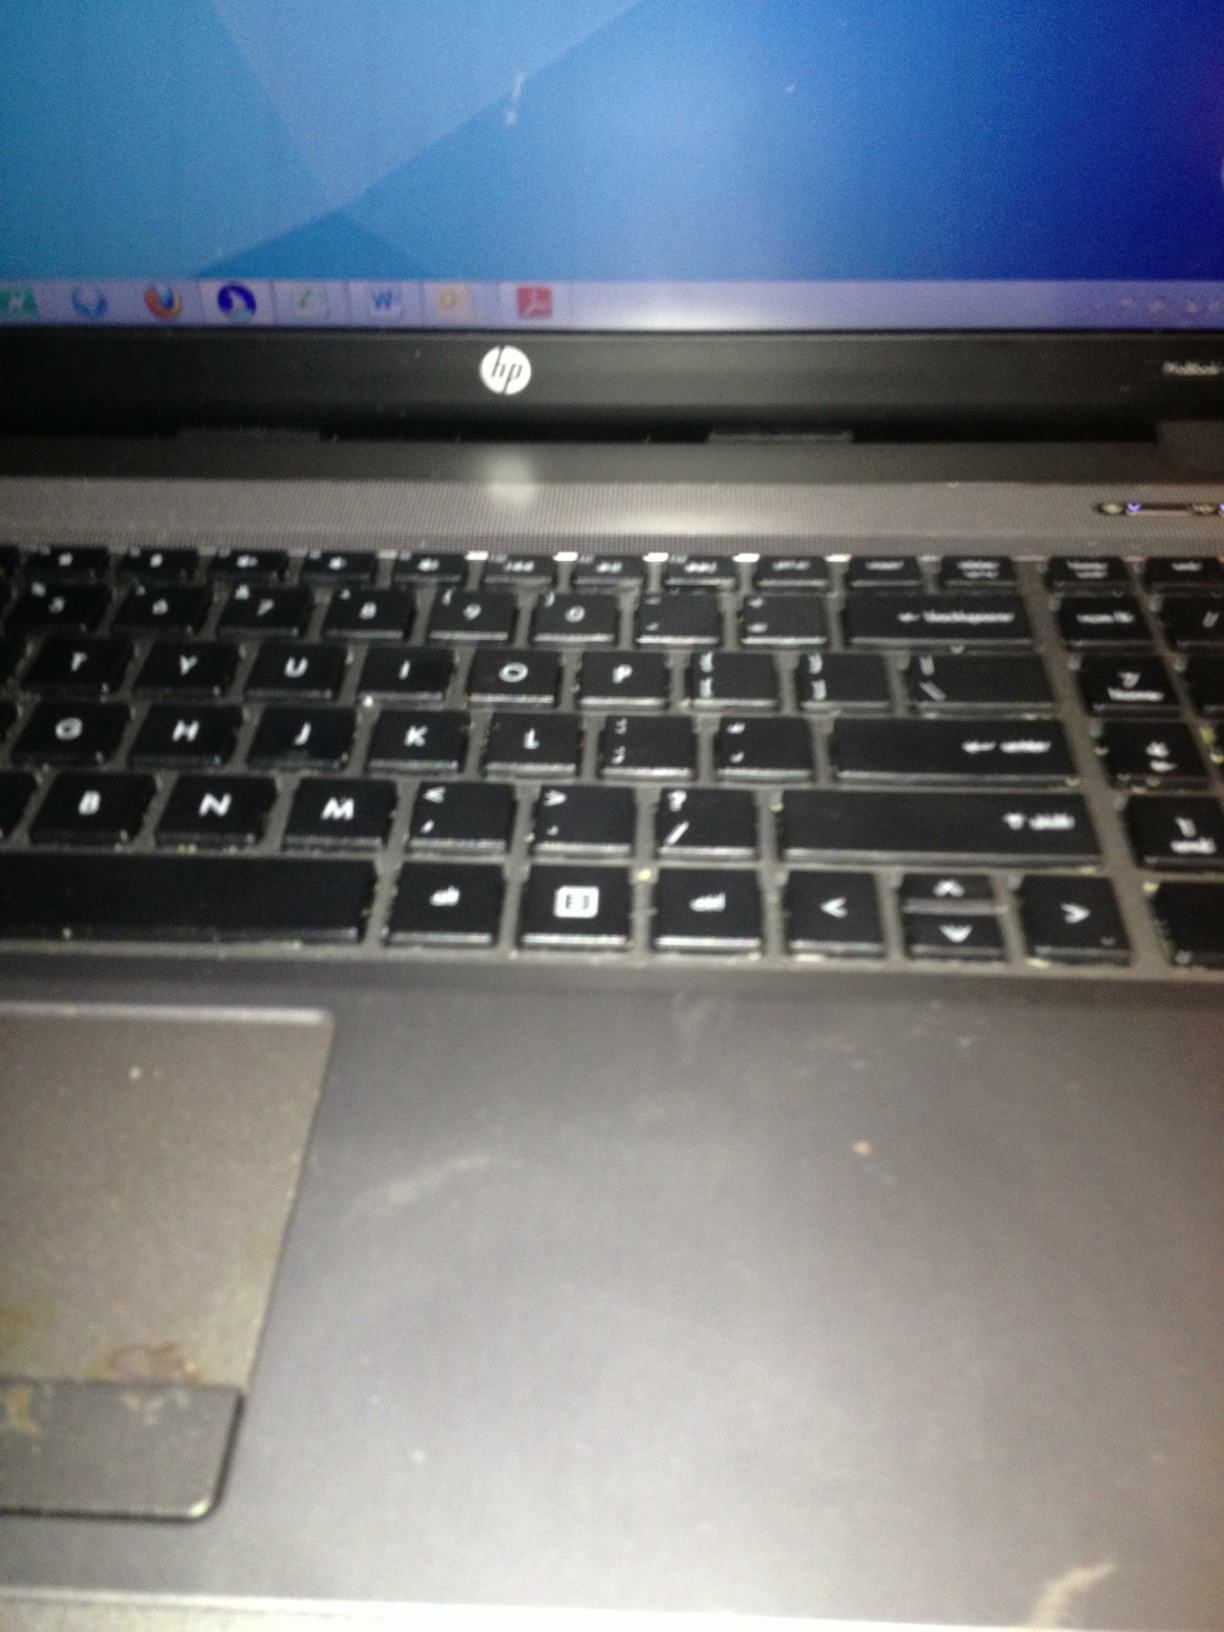What is the battery performance of this laptop likely to be nowadays? Given the visible condition of this HP laptop, the battery performance is likely to have diminished over time. You may notice shorter battery life and a need for more frequent charging compared to when it was new. It might run efficiently for basic tasks, but high-performance applications could drain the battery faster. Consider checking the battery health in the system settings or even opting for a battery replacement if prolonged usage without charging is essential. 